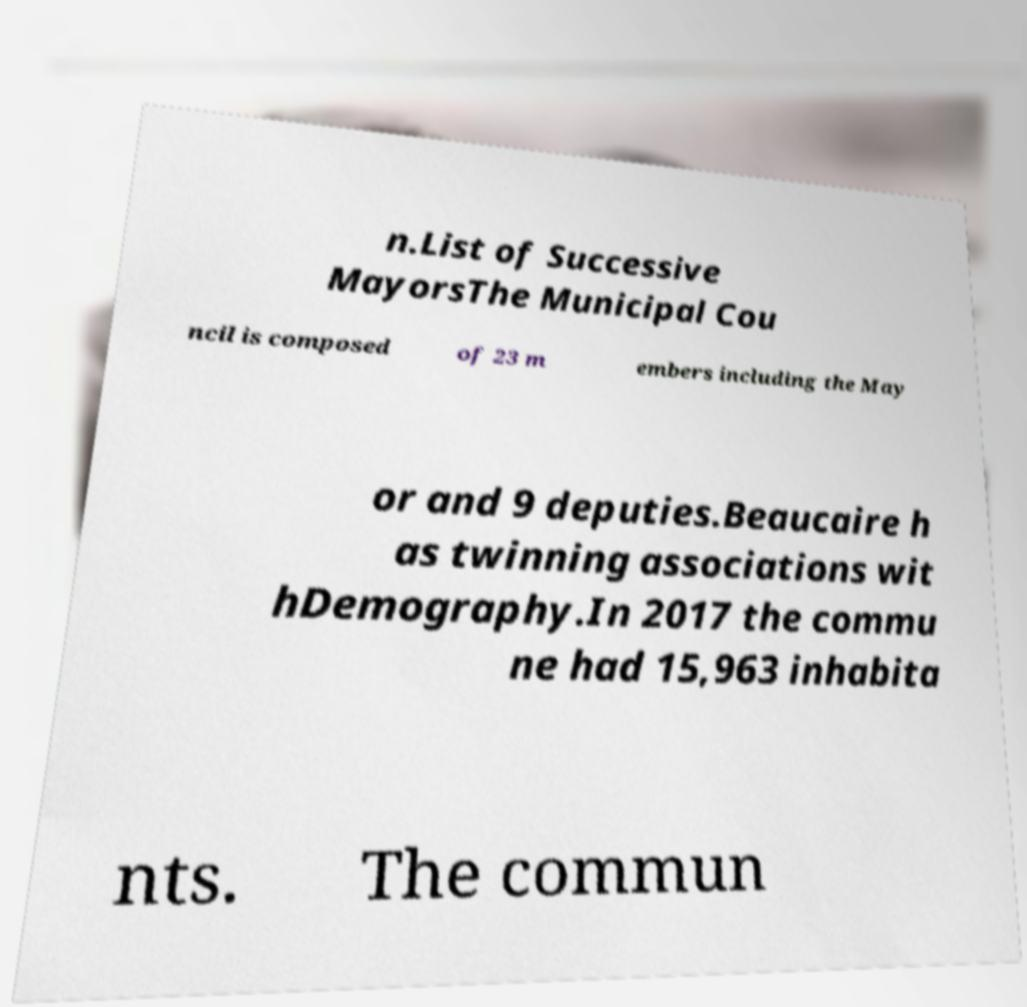There's text embedded in this image that I need extracted. Can you transcribe it verbatim? n.List of Successive MayorsThe Municipal Cou ncil is composed of 23 m embers including the May or and 9 deputies.Beaucaire h as twinning associations wit hDemography.In 2017 the commu ne had 15,963 inhabita nts. The commun 